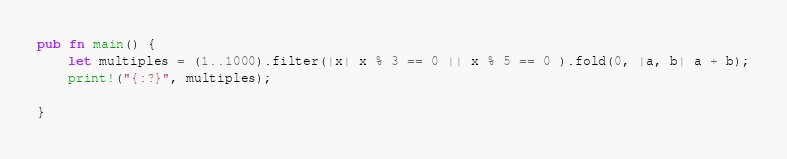<code> <loc_0><loc_0><loc_500><loc_500><_Rust_>pub fn main() {
    let multiples = (1..1000).filter(|x| x % 3 == 0 || x % 5 == 0 ).fold(0, |a, b| a + b);
    print!("{:?}", multiples);

}
</code> 